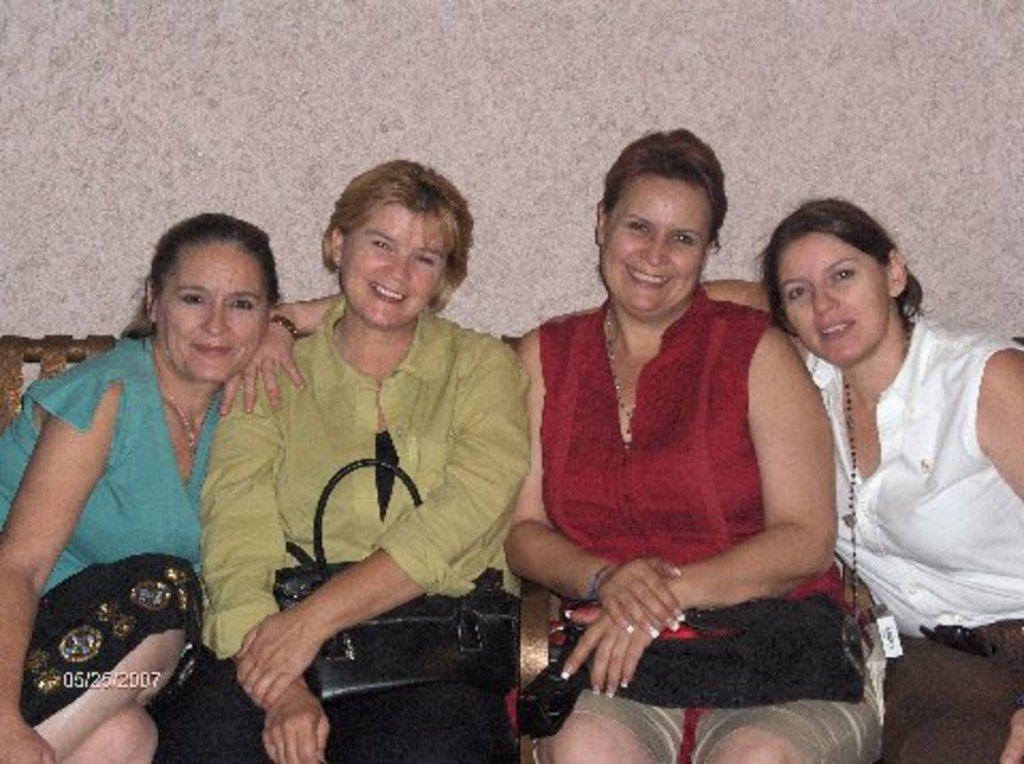Describe this image in one or two sentences. In this image there are persons sitting on a chair and holding bags. And at the background there is a wall. 